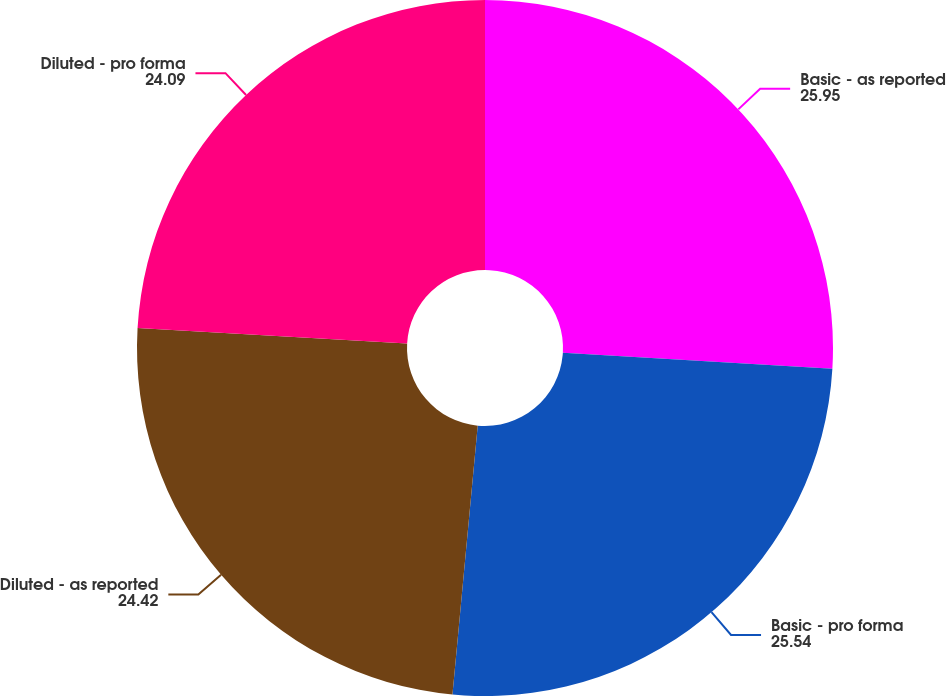<chart> <loc_0><loc_0><loc_500><loc_500><pie_chart><fcel>Basic - as reported<fcel>Basic - pro forma<fcel>Diluted - as reported<fcel>Diluted - pro forma<nl><fcel>25.95%<fcel>25.54%<fcel>24.42%<fcel>24.09%<nl></chart> 